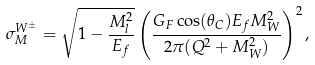<formula> <loc_0><loc_0><loc_500><loc_500>\sigma ^ { W ^ { \pm } } _ { M } = \sqrt { 1 - { \frac { M ^ { 2 } _ { l } } { E _ { f } } } } \left ( { \frac { G _ { F } \cos ( \theta _ { C } ) E _ { f } M _ { W } ^ { 2 } } { 2 \pi ( Q ^ { 2 } + M ^ { 2 } _ { W } ) } } \right ) ^ { 2 } ,</formula> 